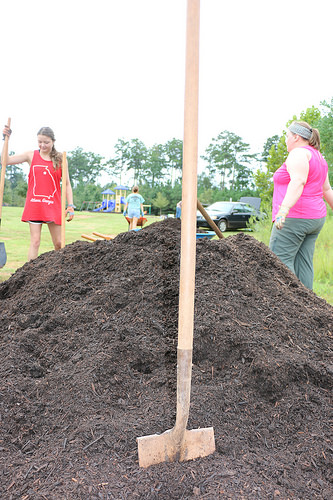<image>
Is the rod on the sand? Yes. Looking at the image, I can see the rod is positioned on top of the sand, with the sand providing support. Is the girl behind the sand? Yes. From this viewpoint, the girl is positioned behind the sand, with the sand partially or fully occluding the girl. Is there a person in the dirt? No. The person is not contained within the dirt. These objects have a different spatial relationship. 